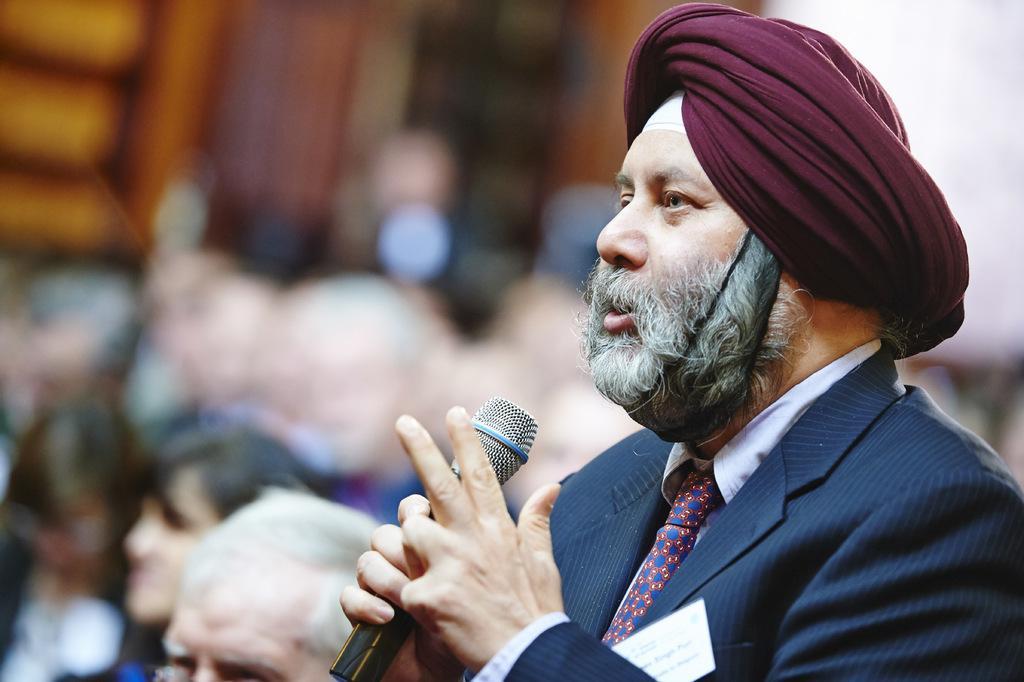Can you describe this image briefly? In this image there is a person wearing blue color suit holding a microphone in his hand. 